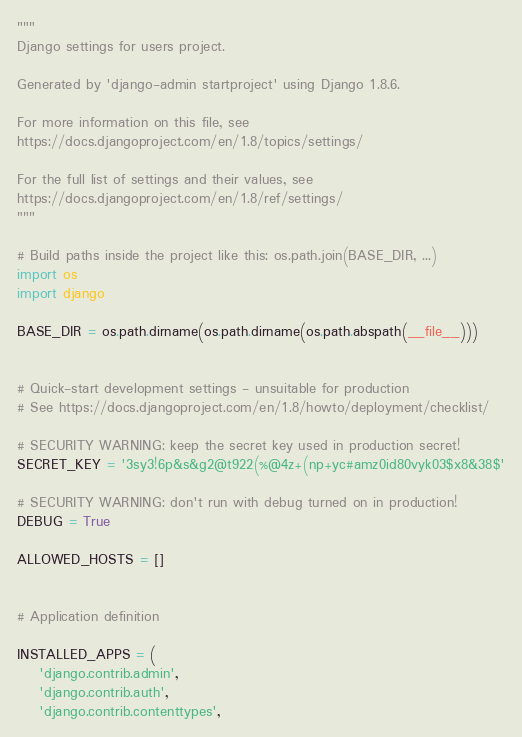<code> <loc_0><loc_0><loc_500><loc_500><_Python_>"""
Django settings for users project.

Generated by 'django-admin startproject' using Django 1.8.6.

For more information on this file, see
https://docs.djangoproject.com/en/1.8/topics/settings/

For the full list of settings and their values, see
https://docs.djangoproject.com/en/1.8/ref/settings/
"""

# Build paths inside the project like this: os.path.join(BASE_DIR, ...)
import os
import django

BASE_DIR = os.path.dirname(os.path.dirname(os.path.abspath(__file__)))


# Quick-start development settings - unsuitable for production
# See https://docs.djangoproject.com/en/1.8/howto/deployment/checklist/

# SECURITY WARNING: keep the secret key used in production secret!
SECRET_KEY = '3sy3!6p&s&g2@t922(%@4z+(np+yc#amz0id80vyk03$x8&38$'

# SECURITY WARNING: don't run with debug turned on in production!
DEBUG = True

ALLOWED_HOSTS = []


# Application definition

INSTALLED_APPS = (
    'django.contrib.admin',
    'django.contrib.auth',
    'django.contrib.contenttypes',</code> 